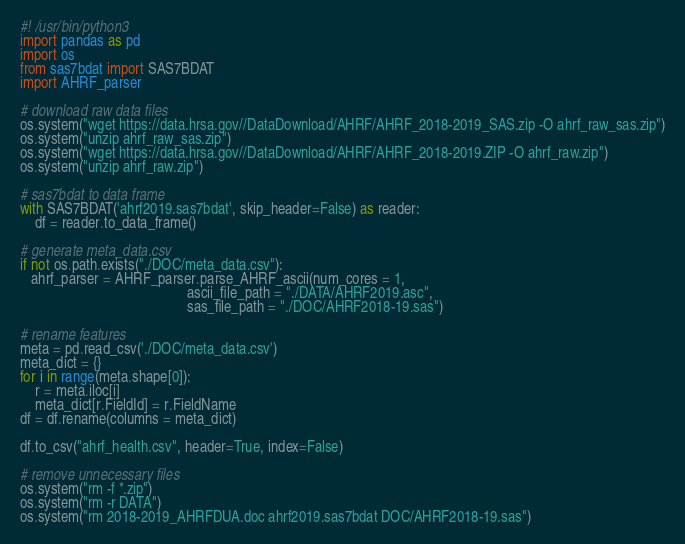<code> <loc_0><loc_0><loc_500><loc_500><_Python_>#! /usr/bin/python3
import pandas as pd
import os
from sas7bdat import SAS7BDAT
import AHRF_parser

# download raw data files
os.system("wget https://data.hrsa.gov//DataDownload/AHRF/AHRF_2018-2019_SAS.zip -O ahrf_raw_sas.zip")
os.system("unzip ahrf_raw_sas.zip")
os.system("wget https://data.hrsa.gov//DataDownload/AHRF/AHRF_2018-2019.ZIP -O ahrf_raw.zip")
os.system("unzip ahrf_raw.zip")

# sas7bdat to data frame
with SAS7BDAT('ahrf2019.sas7bdat', skip_header=False) as reader:
	df = reader.to_data_frame()

# generate meta_data.csv
if not os.path.exists("./DOC/meta_data.csv"):
   ahrf_parser = AHRF_parser.parse_AHRF_ascii(num_cores = 1, 
                                              ascii_file_path = "./DATA/AHRF2019.asc", 
                                              sas_file_path = "./DOC/AHRF2018-19.sas")

# rename features
meta = pd.read_csv('./DOC/meta_data.csv')
meta_dict = {}
for i in range(meta.shape[0]):
    r = meta.iloc[i]
    meta_dict[r.FieldId] = r.FieldName
df = df.rename(columns = meta_dict)

df.to_csv("ahrf_health.csv", header=True, index=False)

# remove unnecessary files
os.system("rm -f *.zip")
os.system("rm -r DATA")
os.system("rm 2018-2019_AHRFDUA.doc ahrf2019.sas7bdat DOC/AHRF2018-19.sas")</code> 